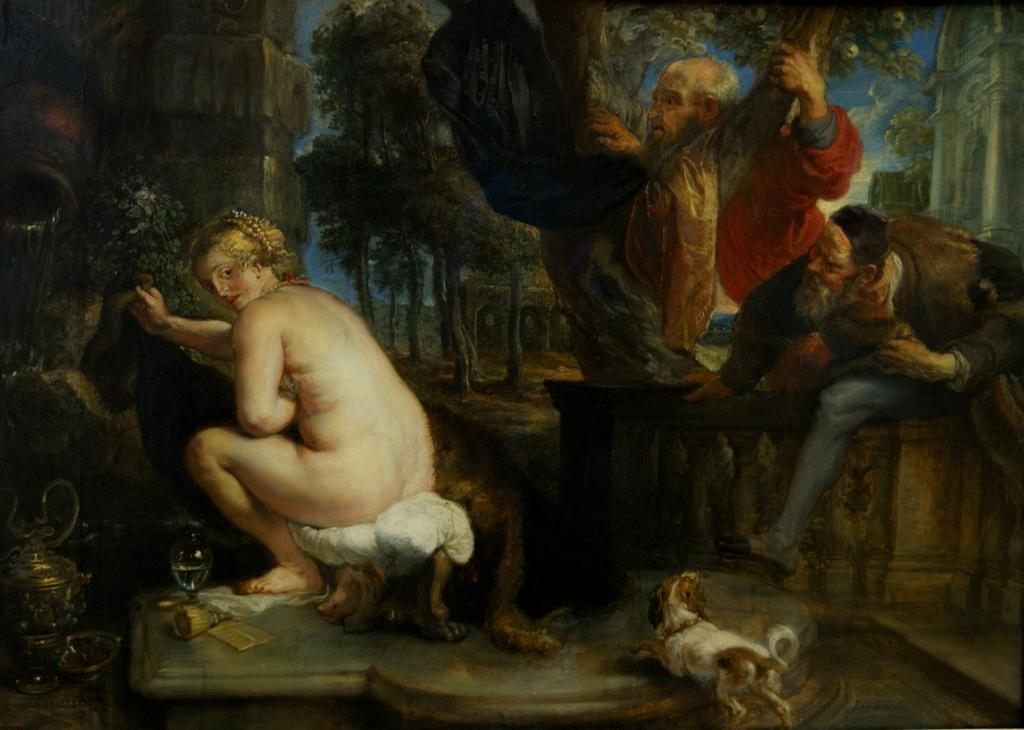What type of natural elements are present in the painting? The painting contains trees. What type of man-made structures are present in the painting? The painting contains buildings. What type of animal is present in the painting? There is a dog in the painting. What type of object is present in the painting that is made of glass? There is a glass object in the painting. What type of living beings are present in the painting besides the dog? There are persons in the painting. How many lizards can be seen climbing on the buildings in the painting? There are no lizards present in the painting; it only features a dog, persons, trees, and buildings. What type of clock is visible on the dog's collar in the painting? There is no clock present in the painting, and the dog is not wearing a collar. 